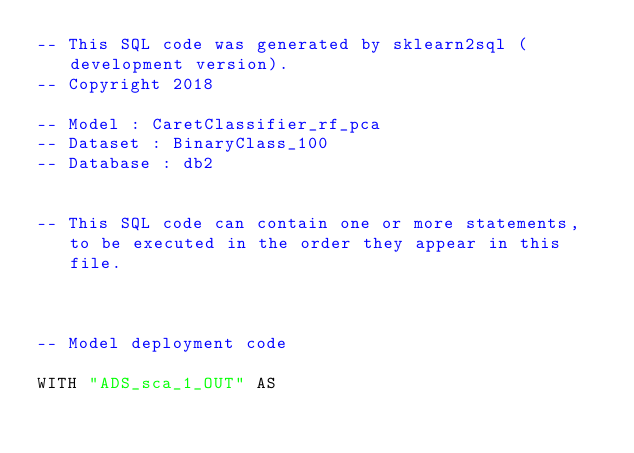<code> <loc_0><loc_0><loc_500><loc_500><_SQL_>-- This SQL code was generated by sklearn2sql (development version).
-- Copyright 2018

-- Model : CaretClassifier_rf_pca
-- Dataset : BinaryClass_100
-- Database : db2


-- This SQL code can contain one or more statements, to be executed in the order they appear in this file.



-- Model deployment code

WITH "ADS_sca_1_OUT" AS </code> 